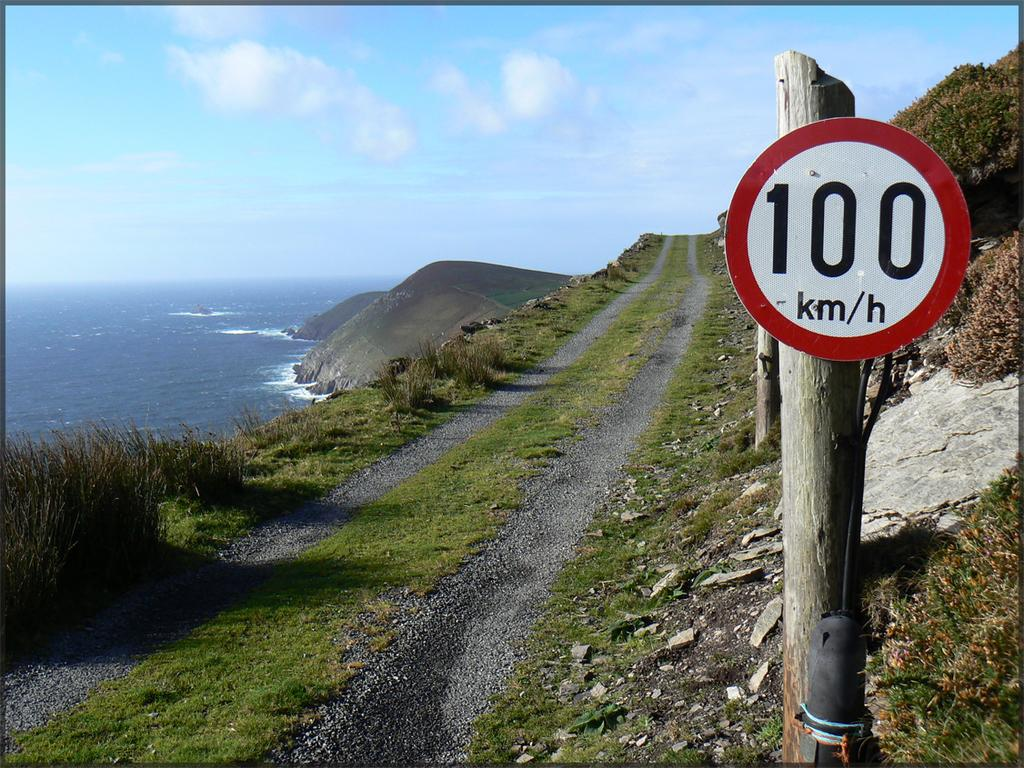Provide a one-sentence caption for the provided image. A narrow cliffside road has a speed limit of 100 km per hour. 